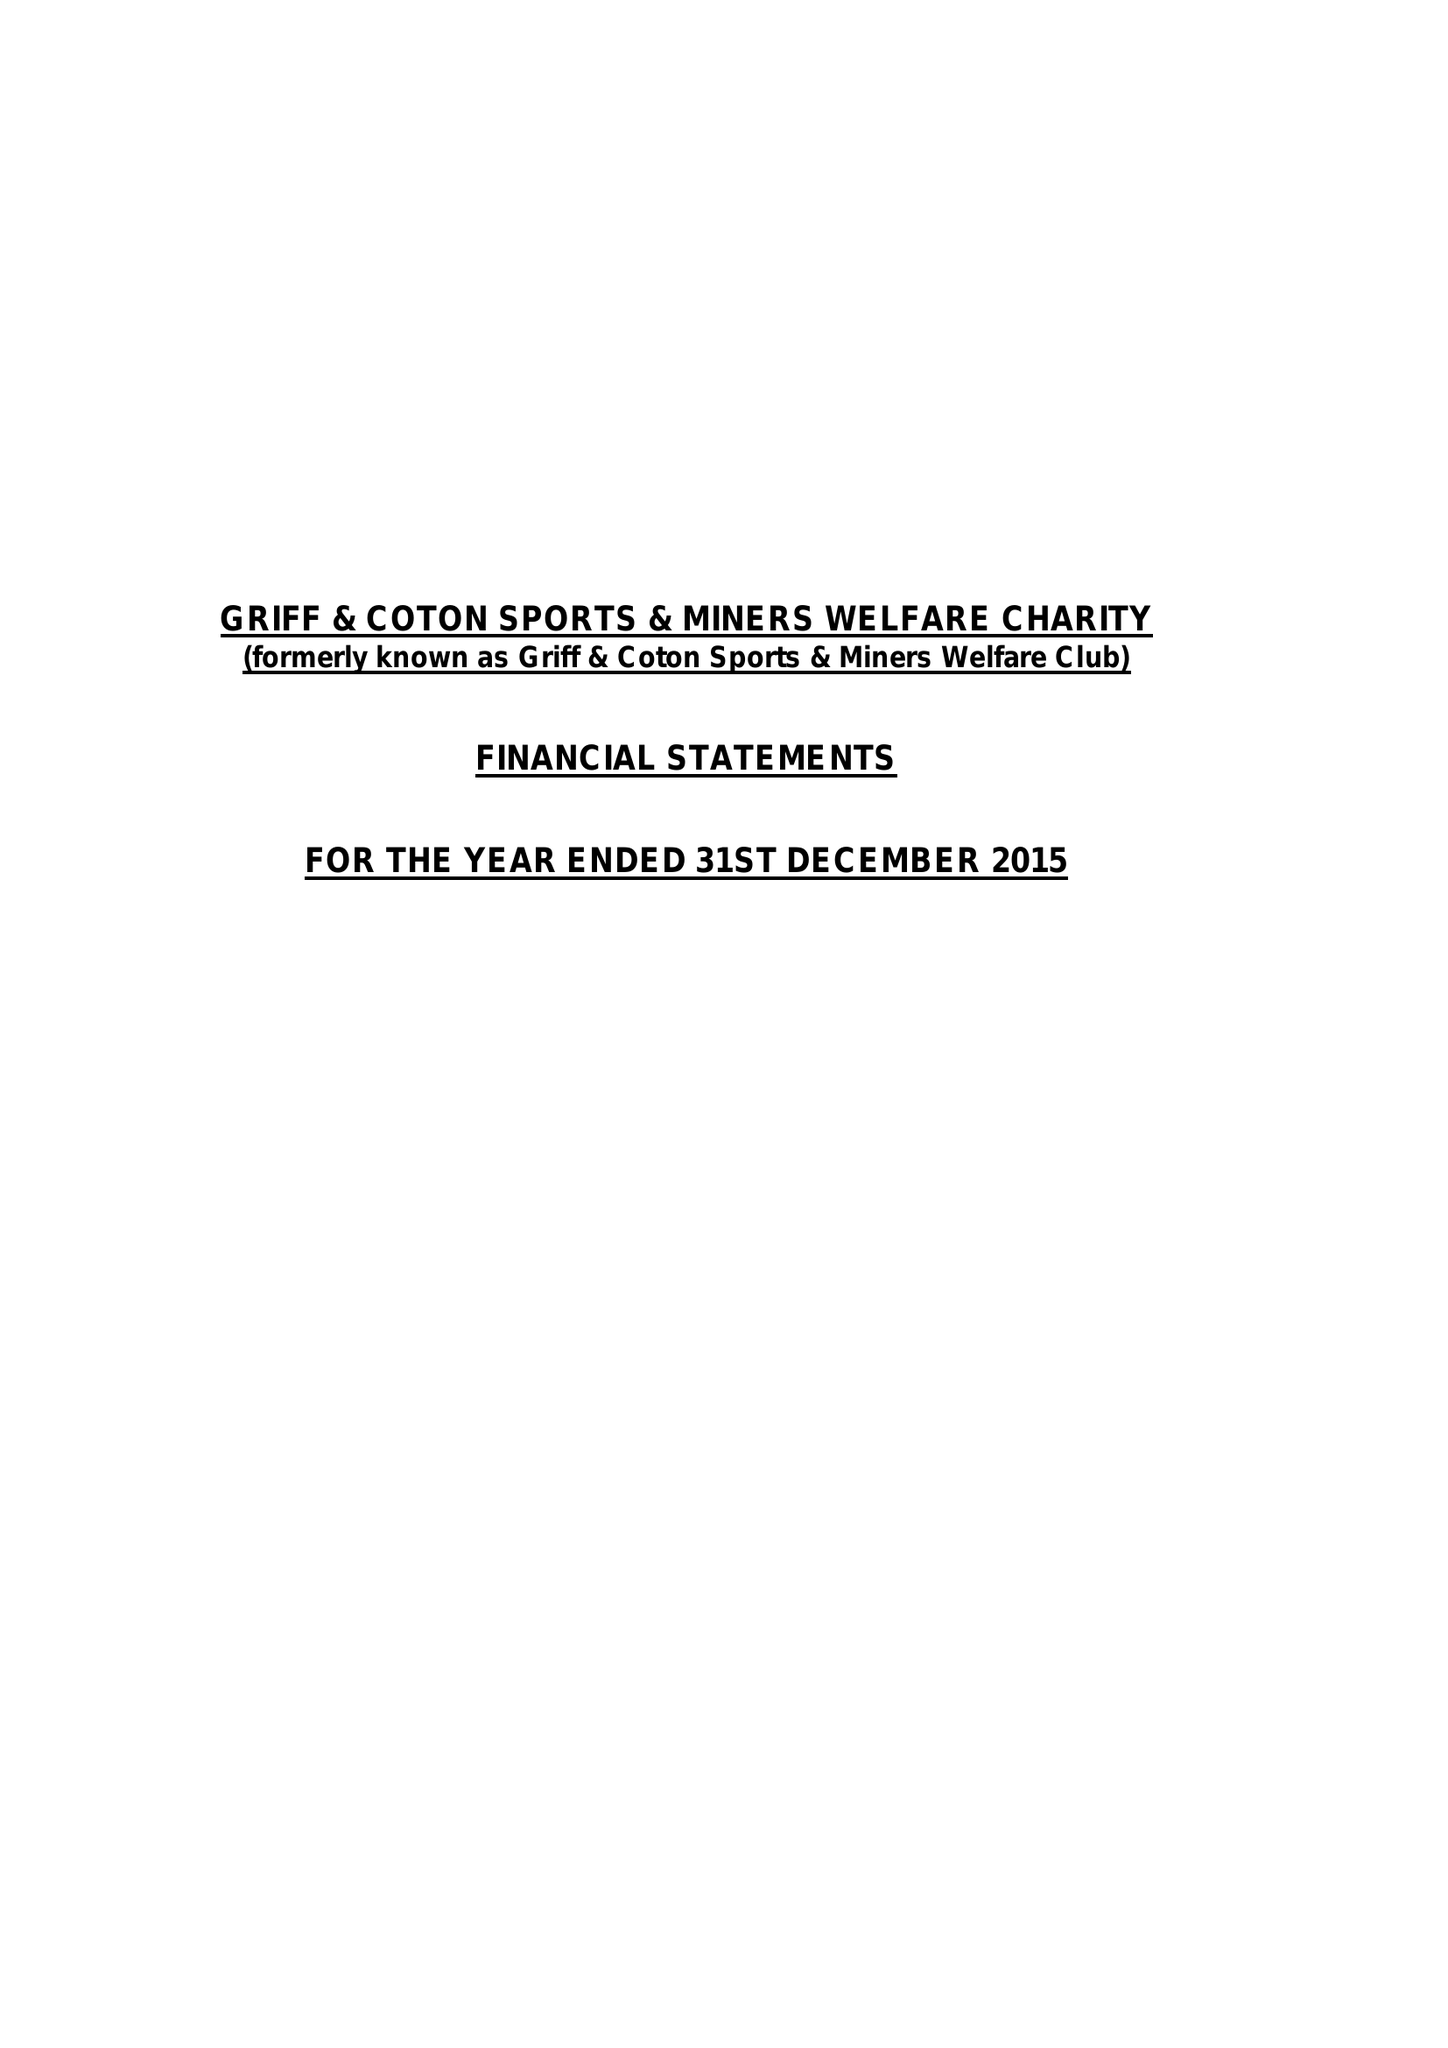What is the value for the charity_number?
Answer the question using a single word or phrase. 522976 